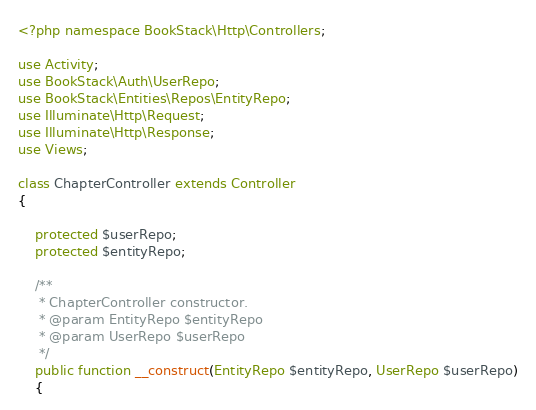<code> <loc_0><loc_0><loc_500><loc_500><_PHP_><?php namespace BookStack\Http\Controllers;

use Activity;
use BookStack\Auth\UserRepo;
use BookStack\Entities\Repos\EntityRepo;
use Illuminate\Http\Request;
use Illuminate\Http\Response;
use Views;

class ChapterController extends Controller
{

    protected $userRepo;
    protected $entityRepo;

    /**
     * ChapterController constructor.
     * @param EntityRepo $entityRepo
     * @param UserRepo $userRepo
     */
    public function __construct(EntityRepo $entityRepo, UserRepo $userRepo)
    {</code> 